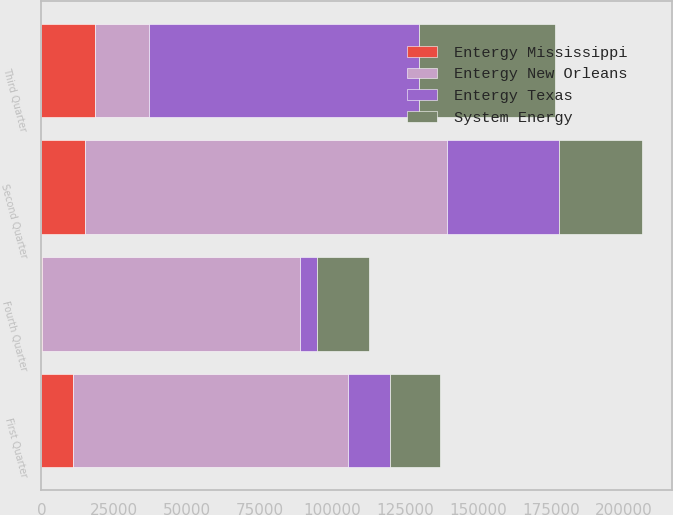Convert chart to OTSL. <chart><loc_0><loc_0><loc_500><loc_500><stacked_bar_chart><ecel><fcel>First Quarter<fcel>Second Quarter<fcel>Third Quarter<fcel>Fourth Quarter<nl><fcel>Entergy Texas<fcel>14304<fcel>38550<fcel>92638<fcel>5648<nl><fcel>Entergy New Orleans<fcel>94378<fcel>124479<fcel>18529<fcel>88794<nl><fcel>System Energy<fcel>17158<fcel>28303<fcel>46545<fcel>18026<nl><fcel>Entergy Mississippi<fcel>10978<fcel>14882<fcel>18529<fcel>164<nl></chart> 